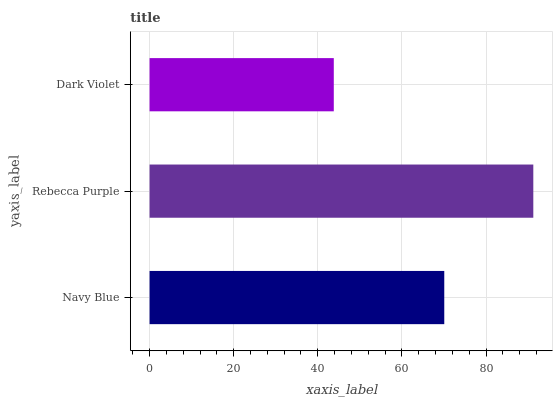Is Dark Violet the minimum?
Answer yes or no. Yes. Is Rebecca Purple the maximum?
Answer yes or no. Yes. Is Rebecca Purple the minimum?
Answer yes or no. No. Is Dark Violet the maximum?
Answer yes or no. No. Is Rebecca Purple greater than Dark Violet?
Answer yes or no. Yes. Is Dark Violet less than Rebecca Purple?
Answer yes or no. Yes. Is Dark Violet greater than Rebecca Purple?
Answer yes or no. No. Is Rebecca Purple less than Dark Violet?
Answer yes or no. No. Is Navy Blue the high median?
Answer yes or no. Yes. Is Navy Blue the low median?
Answer yes or no. Yes. Is Dark Violet the high median?
Answer yes or no. No. Is Rebecca Purple the low median?
Answer yes or no. No. 